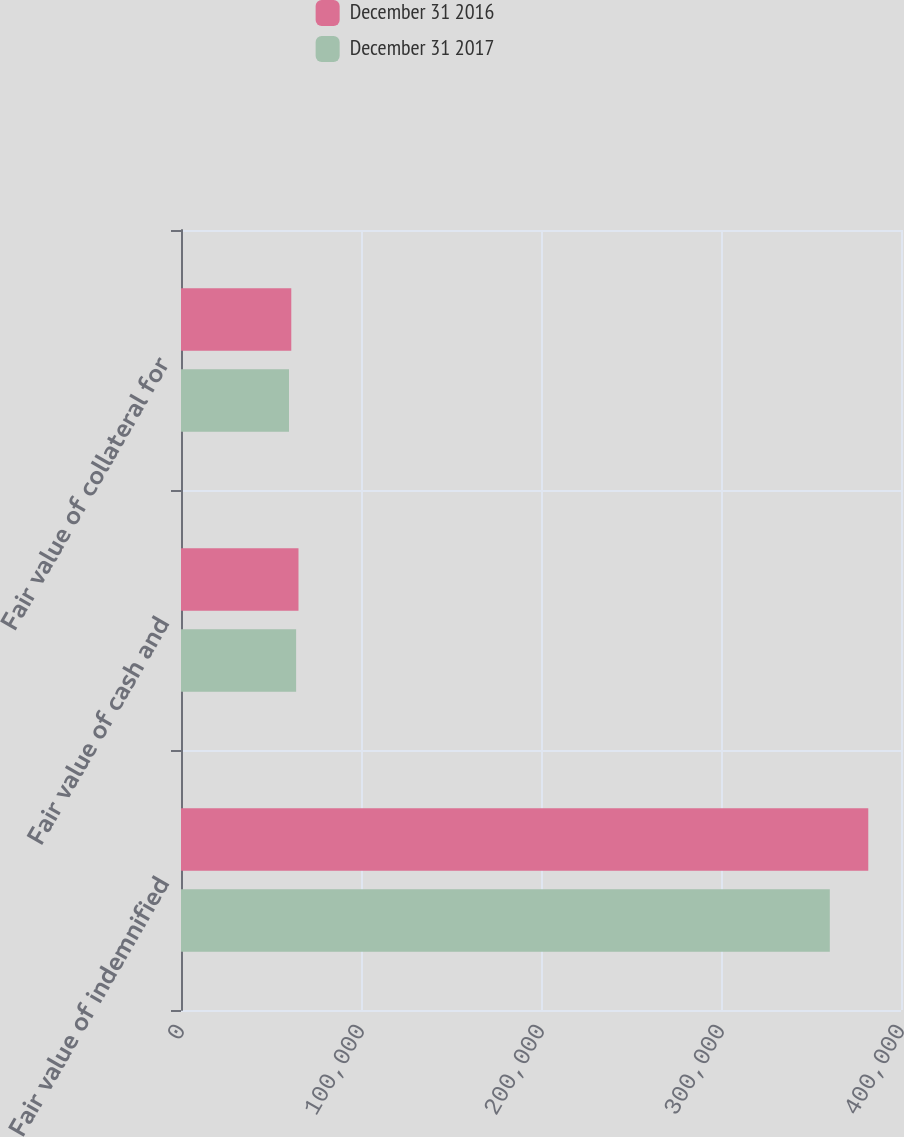Convert chart to OTSL. <chart><loc_0><loc_0><loc_500><loc_500><stacked_bar_chart><ecel><fcel>Fair value of indemnified<fcel>Fair value of cash and<fcel>Fair value of collateral for<nl><fcel>December 31 2016<fcel>381817<fcel>65272<fcel>61270<nl><fcel>December 31 2017<fcel>360452<fcel>63959<fcel>60003<nl></chart> 